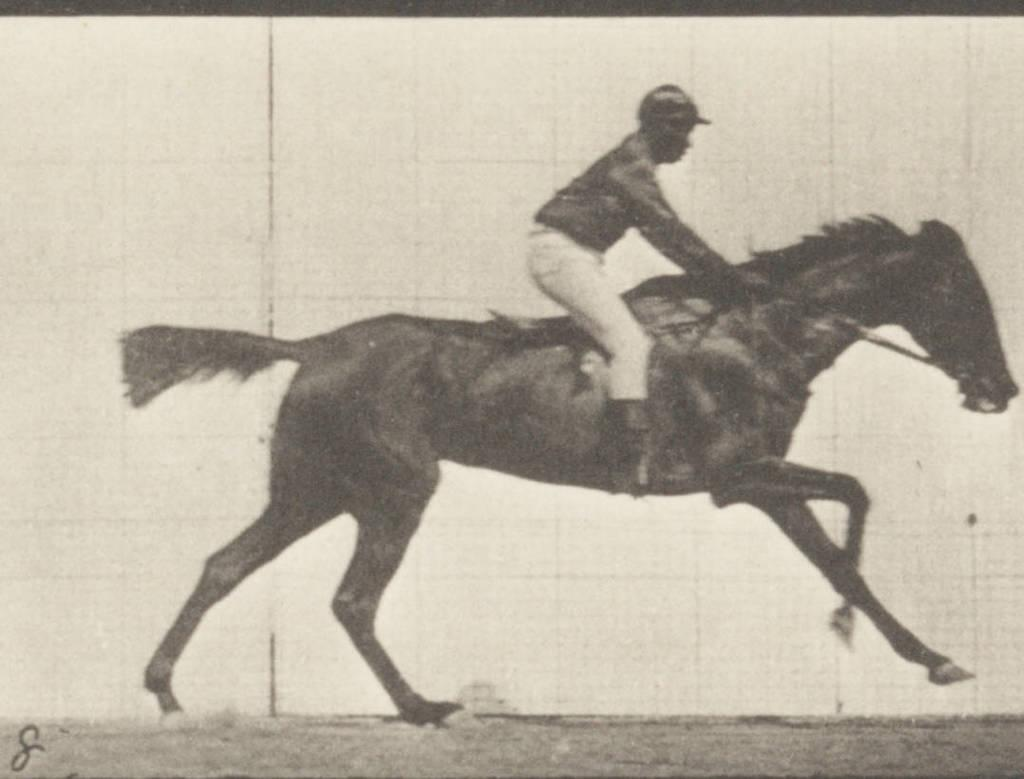What is the color scheme of the image? The image is black and white. Can you describe the main subject of the image? There is a person in the image. What is the person doing in the image? The person is on a horse. How many thumbs can be seen on the person's hands in the image? There is no way to determine the number of thumbs on the person's hands in the black and white image. What date is marked on the calendar in the image? There is no calendar present in the image. 